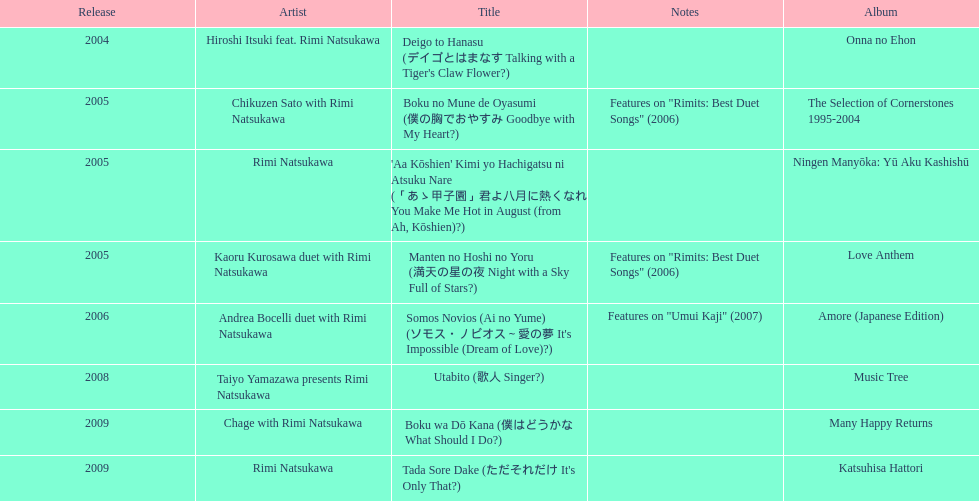Which year had the most titles released? 2005. Parse the full table. {'header': ['Release', 'Artist', 'Title', 'Notes', 'Album'], 'rows': [['2004', 'Hiroshi Itsuki feat. Rimi Natsukawa', "Deigo to Hanasu (デイゴとはまなす Talking with a Tiger's Claw Flower?)", '', 'Onna no Ehon'], ['2005', 'Chikuzen Sato with Rimi Natsukawa', 'Boku no Mune de Oyasumi (僕の胸でおやすみ Goodbye with My Heart?)', 'Features on "Rimits: Best Duet Songs" (2006)', 'The Selection of Cornerstones 1995-2004'], ['2005', 'Rimi Natsukawa', "'Aa Kōshien' Kimi yo Hachigatsu ni Atsuku Nare (「あゝ甲子園」君よ八月に熱くなれ You Make Me Hot in August (from Ah, Kōshien)?)", '', 'Ningen Manyōka: Yū Aku Kashishū'], ['2005', 'Kaoru Kurosawa duet with Rimi Natsukawa', 'Manten no Hoshi no Yoru (満天の星の夜 Night with a Sky Full of Stars?)', 'Features on "Rimits: Best Duet Songs" (2006)', 'Love Anthem'], ['2006', 'Andrea Bocelli duet with Rimi Natsukawa', "Somos Novios (Ai no Yume) (ソモス・ノビオス～愛の夢 It's Impossible (Dream of Love)?)", 'Features on "Umui Kaji" (2007)', 'Amore (Japanese Edition)'], ['2008', 'Taiyo Yamazawa presents Rimi Natsukawa', 'Utabito (歌人 Singer?)', '', 'Music Tree'], ['2009', 'Chage with Rimi Natsukawa', 'Boku wa Dō Kana (僕はどうかな What Should I Do?)', '', 'Many Happy Returns'], ['2009', 'Rimi Natsukawa', "Tada Sore Dake (ただそれだけ It's Only That?)", '', 'Katsuhisa Hattori']]} 